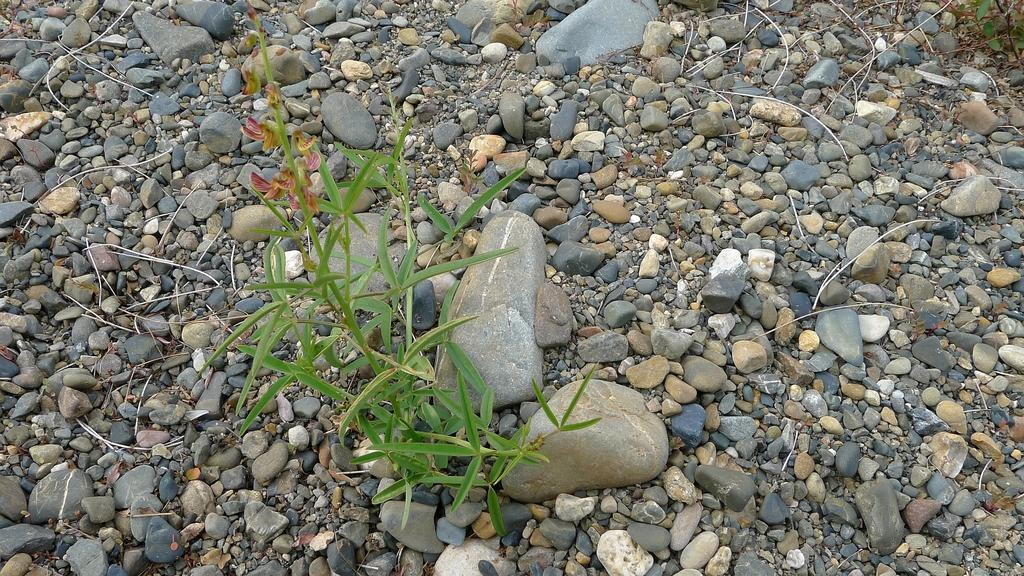What type of plant is visible in the image? There is a small plant in the image. Where is the plant located? The plant is on the ground. What is covering the ground in the image? The ground is covered with stones. What time of day is it in the image, and what is the shocking event that occurs? The time of day is not mentioned in the image, and there is no shocking event depicted. 